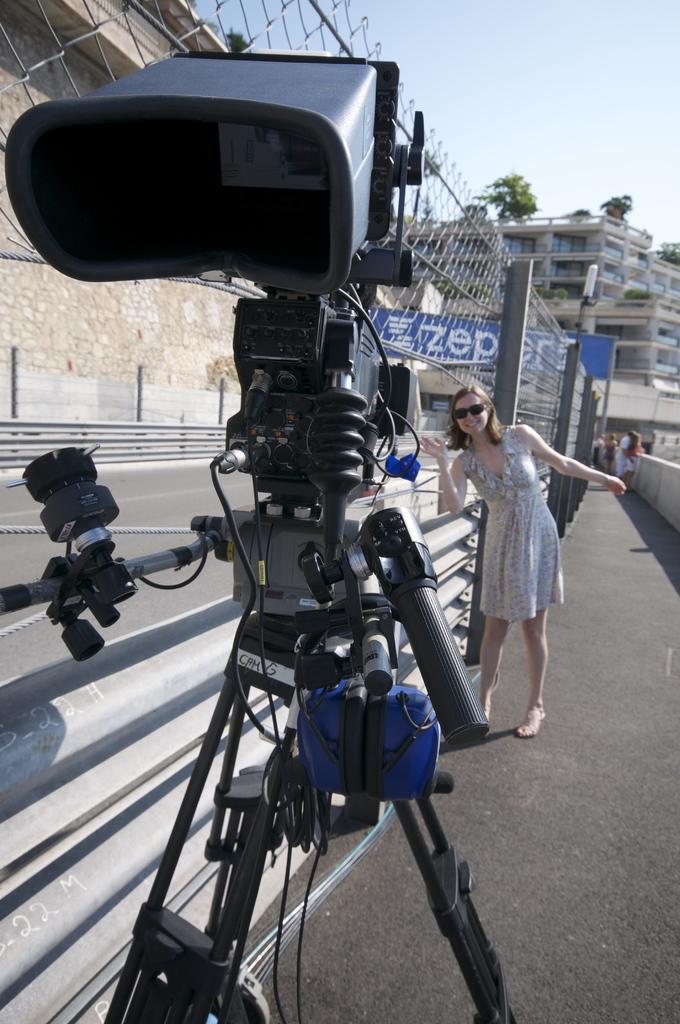Could you give a brief overview of what you see in this image? There is a video camera on a stand. Also there is a lady wearing goggles is standing. In the back there is a road, wall, railing, banners, buildings, trees and sky. 